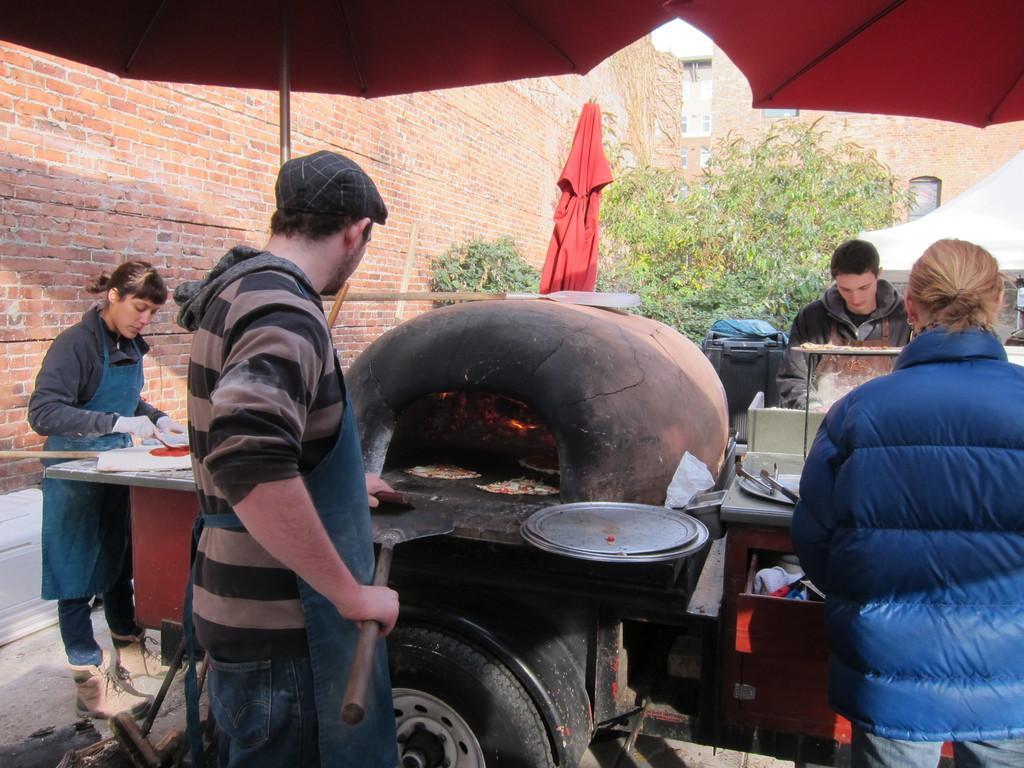How would you summarize this image in a sentence or two? In the image we can see there are two men and two women standing, wearing clothes and here we can see plate, flame, food items and a table. Here we can see a tire, tree and brick building. Here we can see tent and umbrella. 